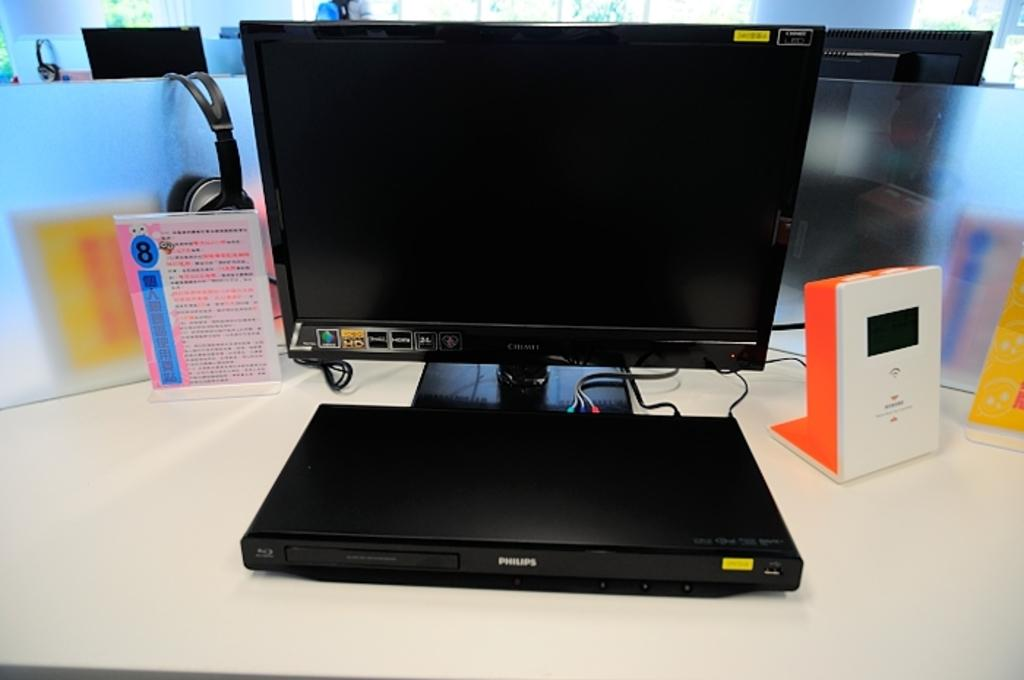Provide a one-sentence caption for the provided image. A sticker on a computer monitor displays its HD capability. 